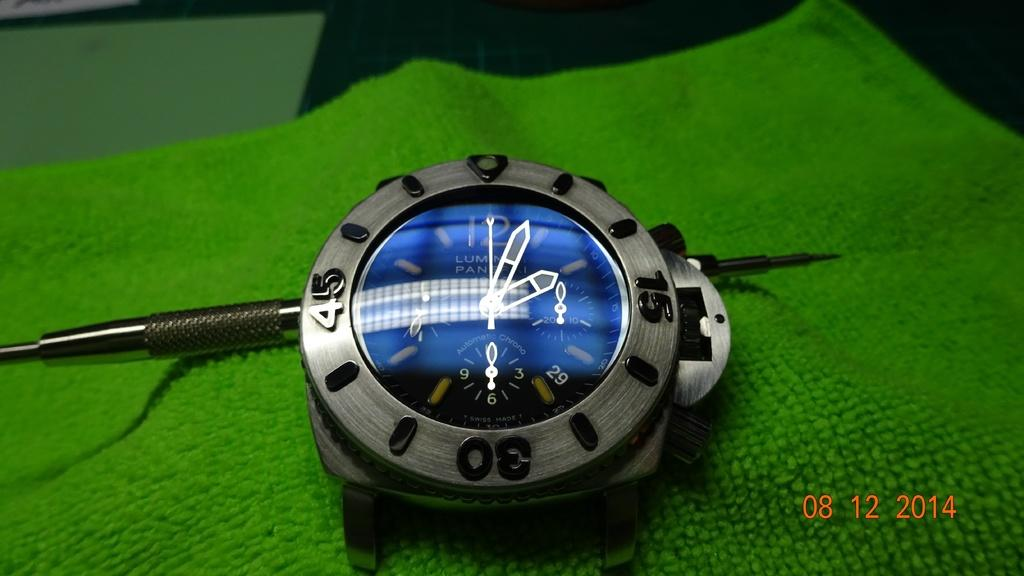<image>
Offer a succinct explanation of the picture presented. A picture of a watch taken in 2014 sits on a green cloth 